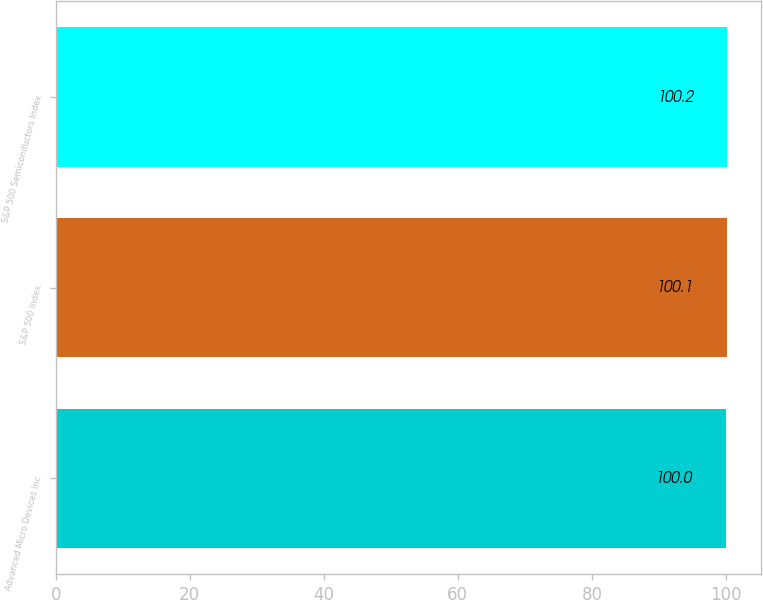Convert chart. <chart><loc_0><loc_0><loc_500><loc_500><bar_chart><fcel>Advanced Micro Devices Inc<fcel>S&P 500 Index<fcel>S&P 500 Semiconductors Index<nl><fcel>100<fcel>100.1<fcel>100.2<nl></chart> 